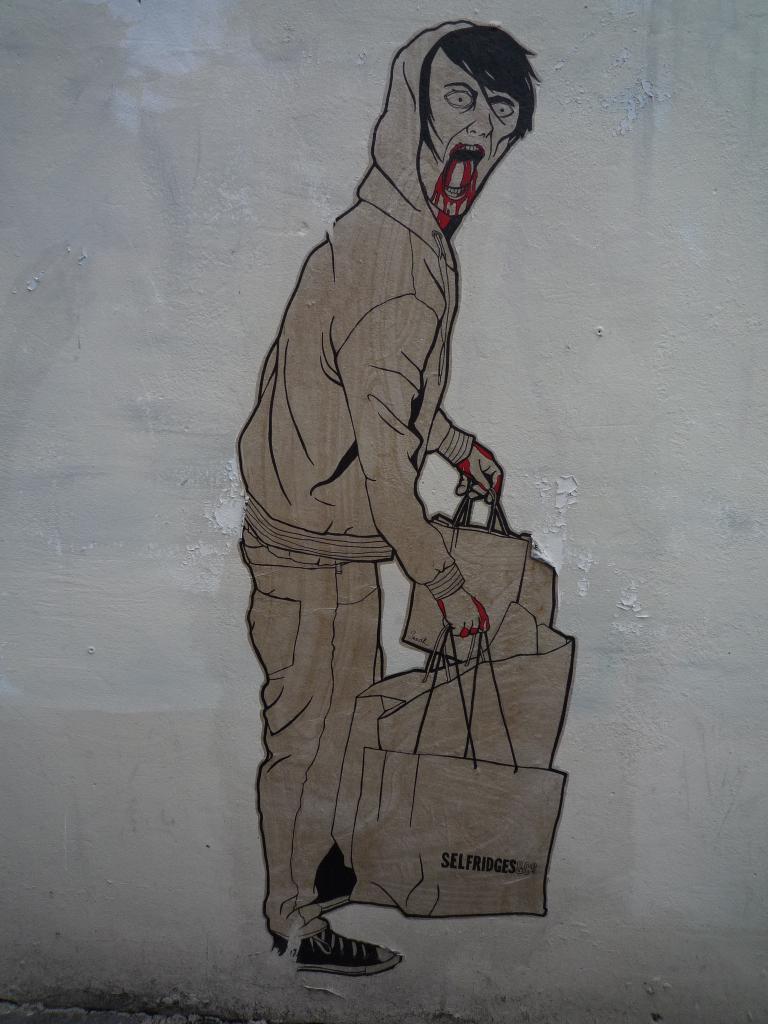Describe this image in one or two sentences. In the picture I can see the painting of a person in the zombie costume and the persons is holding the bags in his hands. 